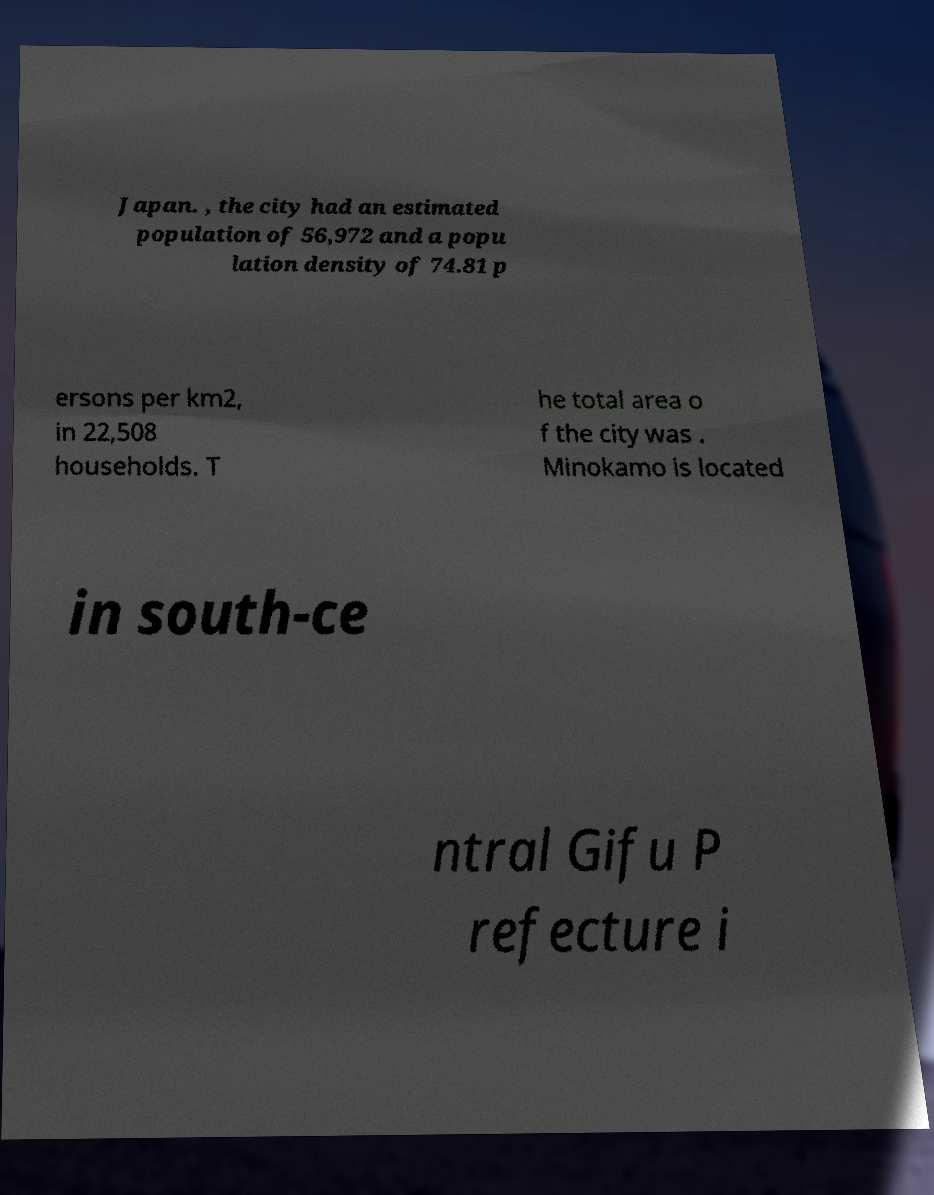Can you read and provide the text displayed in the image?This photo seems to have some interesting text. Can you extract and type it out for me? Japan. , the city had an estimated population of 56,972 and a popu lation density of 74.81 p ersons per km2, in 22,508 households. T he total area o f the city was . Minokamo is located in south-ce ntral Gifu P refecture i 